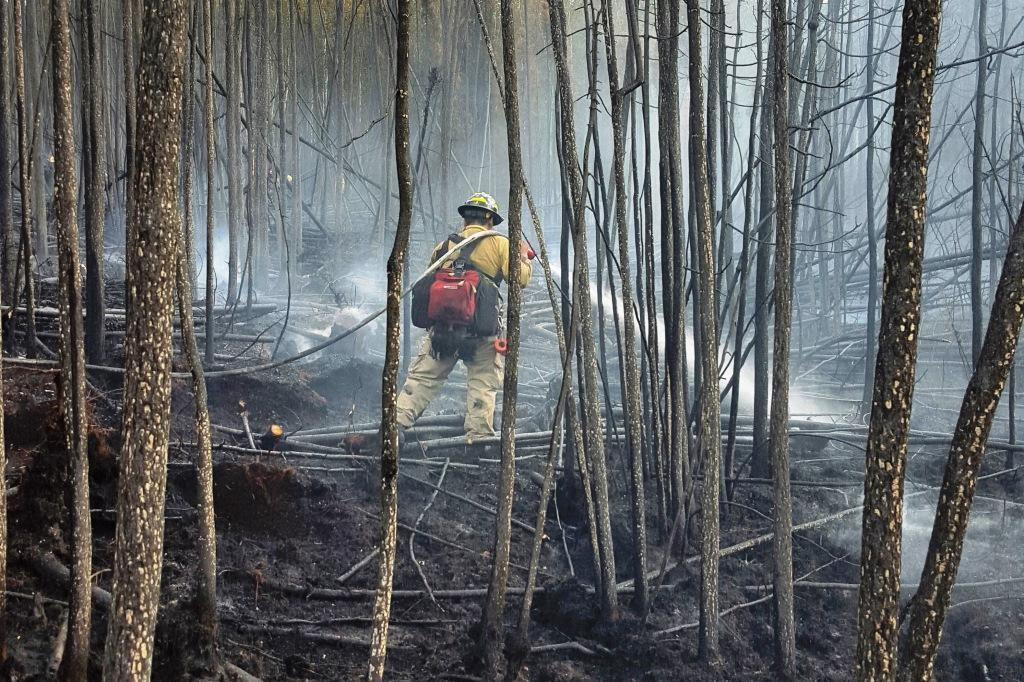What type of natural feature can be seen in the image? The bark of trees is visible in the image. Can you describe the person in the image? There is a person standing in the middle of the image. What type of dolls can be seen on the street in the image? There are no dolls or streets present in the image; it features the bark of trees and a person standing in the middle. 